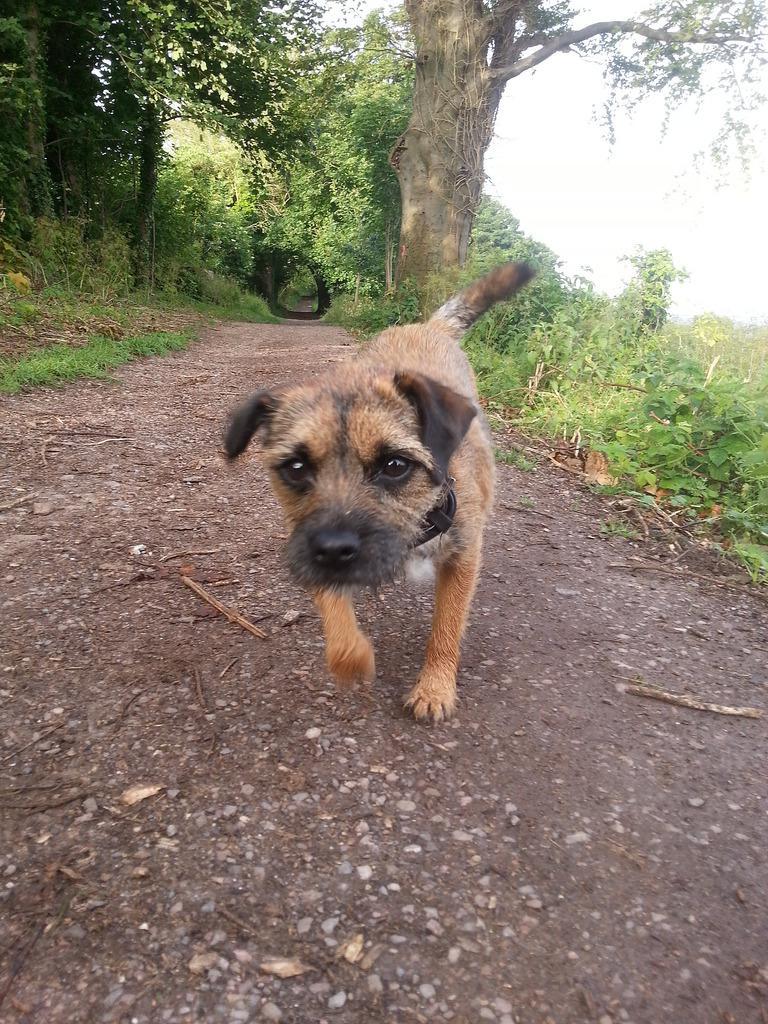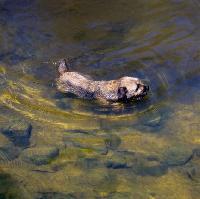The first image is the image on the left, the second image is the image on the right. Assess this claim about the two images: "In the image on the left, there isn't any body of water.". Correct or not? Answer yes or no. Yes. The first image is the image on the left, the second image is the image on the right. Assess this claim about the two images: "Only one of the images shows a dog in a scene with water, and that image shows the bottom ground underneath the water.". Correct or not? Answer yes or no. Yes. 